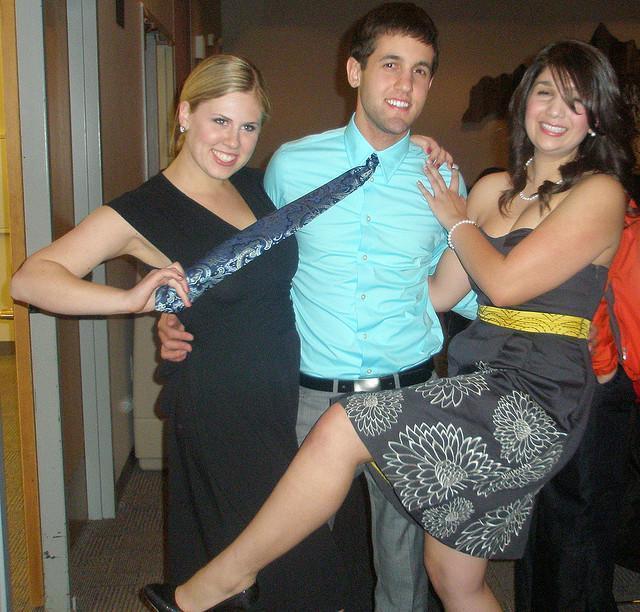How many people are there?
Give a very brief answer. 3. 